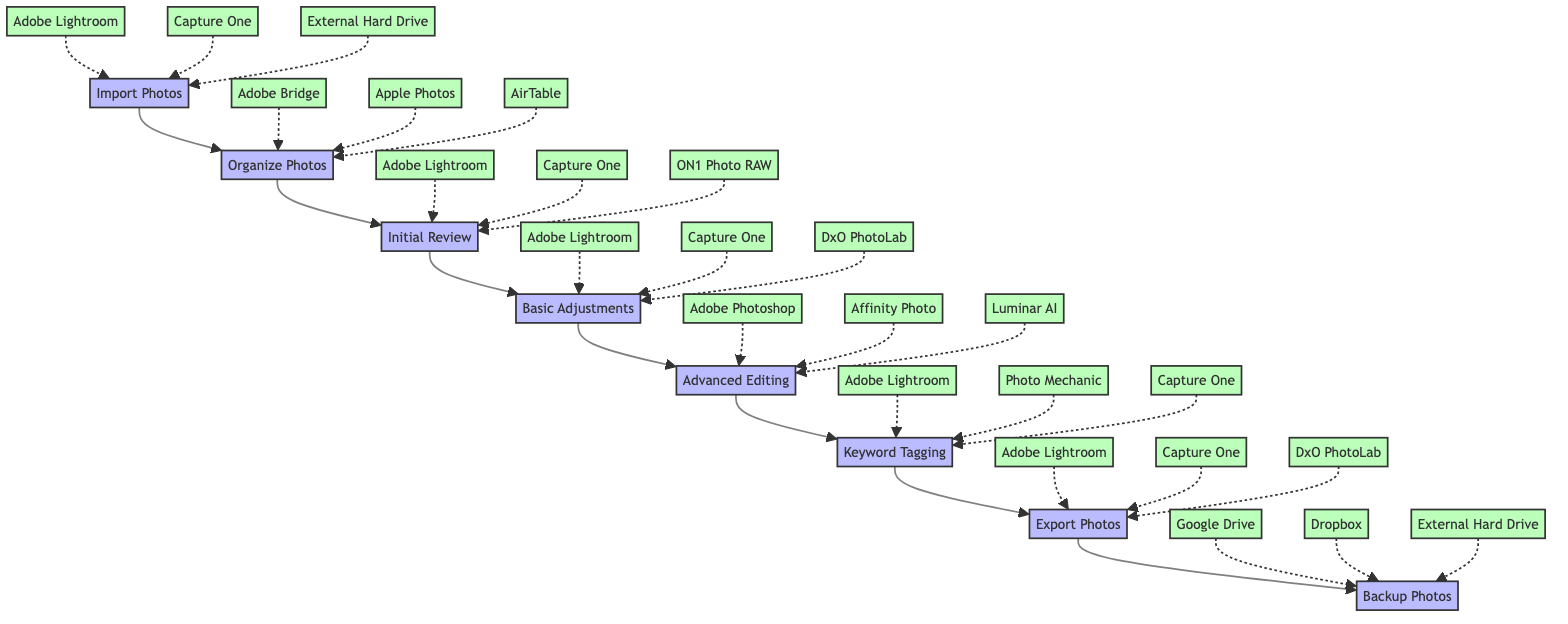What is the first step in the workflow? The first step in the workflow is to "Import Photos," which signifies the starting point of the process.
Answer: Import Photos How long does it take to organize photos? According to the diagram, organizing photos takes "2 hours," which is specified as the duration for this step.
Answer: 2 hours Which tool is used for keyword tagging? In the workflow, "Adobe Lightroom" is listed as one of the tools used for keyword tagging, indicating its importance in this task.
Answer: Adobe Lightroom What is the last step in the workflow? The last step in the workflow is "Backup Photos," which indicates the final action taken after all editing processes are completed.
Answer: Backup Photos How many total steps are in the workflow? The workflow contains a total of 8 steps, as indicated by the number of distinct actions listed within the diagram.
Answer: 8 What are the tools mentioned for Advanced Editing? The tools used for Advanced Editing are "Adobe Photoshop," "Affinity Photo," and "Luminar AI," which provide various options for enhancing images.
Answer: Adobe Photoshop, Affinity Photo, Luminar AI Which step involves adding keywords? The step that involves adding keywords is "Keyword Tagging," as indicated clearly in the workflow sequence.
Answer: Keyword Tagging What is the duration for Advanced Editing? The duration for Advanced Editing is "3-4 hours," showing that this step may vary in time based on the complexity of the images being edited.
Answer: 3-4 hours Which tools can be used to export photos? The tools available for exporting photos are "Adobe Lightroom," "Capture One," and "DxO PhotoLab," all of which are specified for this step.
Answer: Adobe Lightroom, Capture One, DxO PhotoLab 